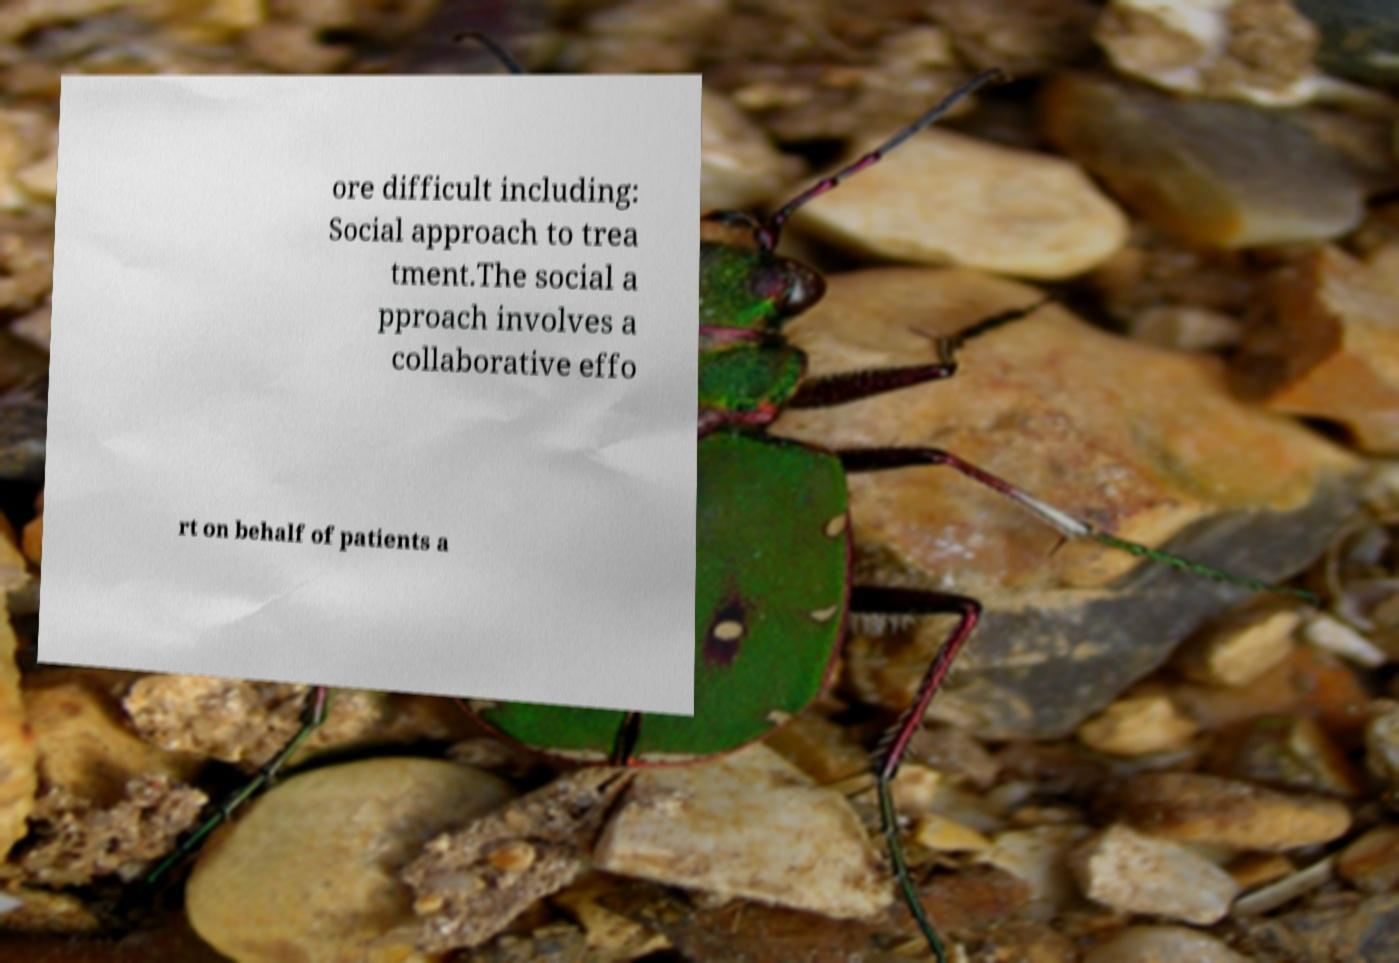Can you accurately transcribe the text from the provided image for me? ore difficult including: Social approach to trea tment.The social a pproach involves a collaborative effo rt on behalf of patients a 